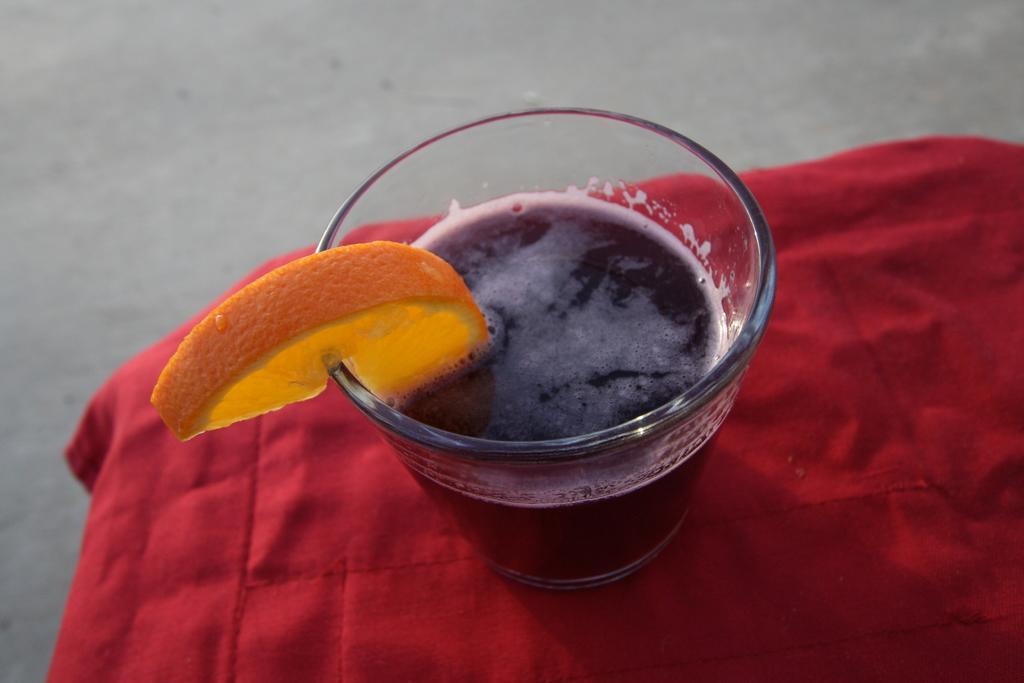Could you give a brief overview of what you see in this image? In this picture I can see the coke glass. At the top I can see the piece of orange. At the bottom I can see the red cloth which is covered to the table. At the top there is a floor. 